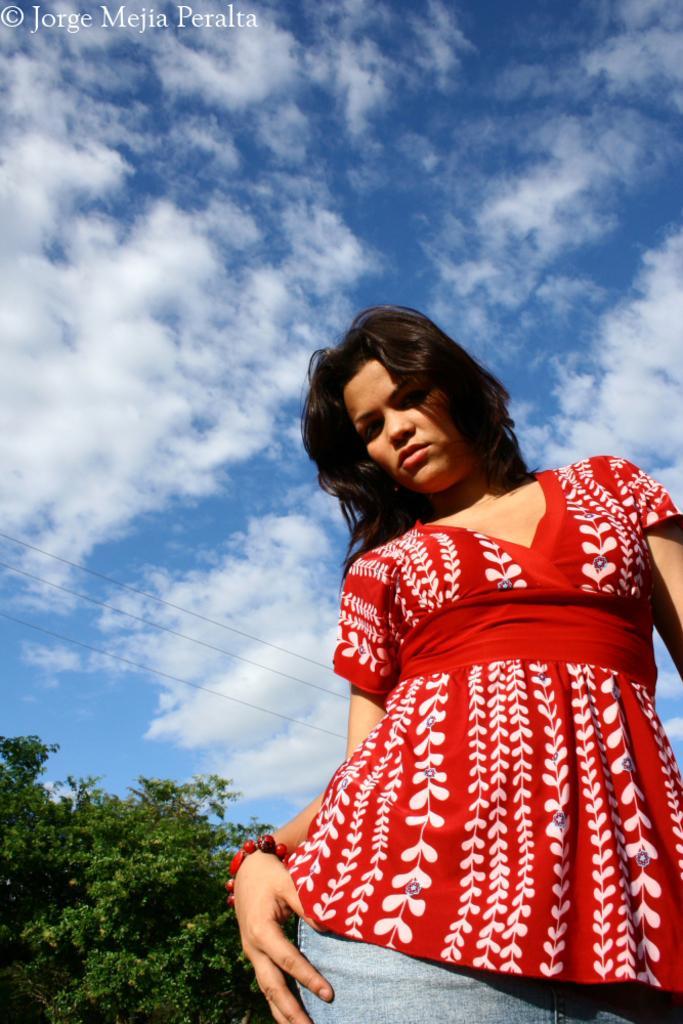In one or two sentences, can you explain what this image depicts? As we can see in the image there is a woman wearing red color dress. There are trees, sky and clouds. 